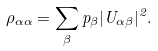Convert formula to latex. <formula><loc_0><loc_0><loc_500><loc_500>\rho _ { \alpha \alpha } = \sum _ { \beta } p _ { \beta } | U _ { \alpha \beta } | ^ { 2 } .</formula> 